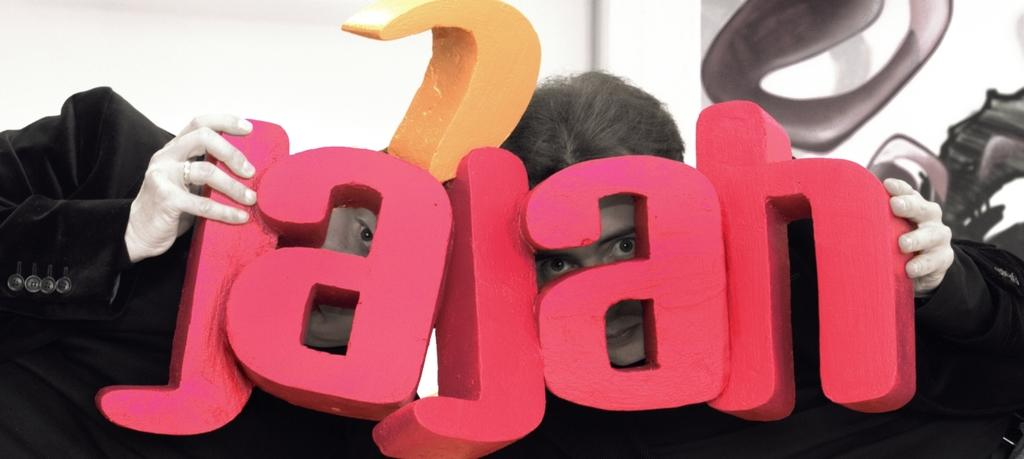How many people are present in the image? There are two people in the image. What are the people holding in their hands? The people are holding something in their hands, but the specific object is not mentioned in the facts. What is the color of the background in the image? The background of the image is white in color. What grade did the person on the left receive for their performance in the image? There is no indication of a performance or grade in the image, as it only shows two people holding something in their hands with a white background. 